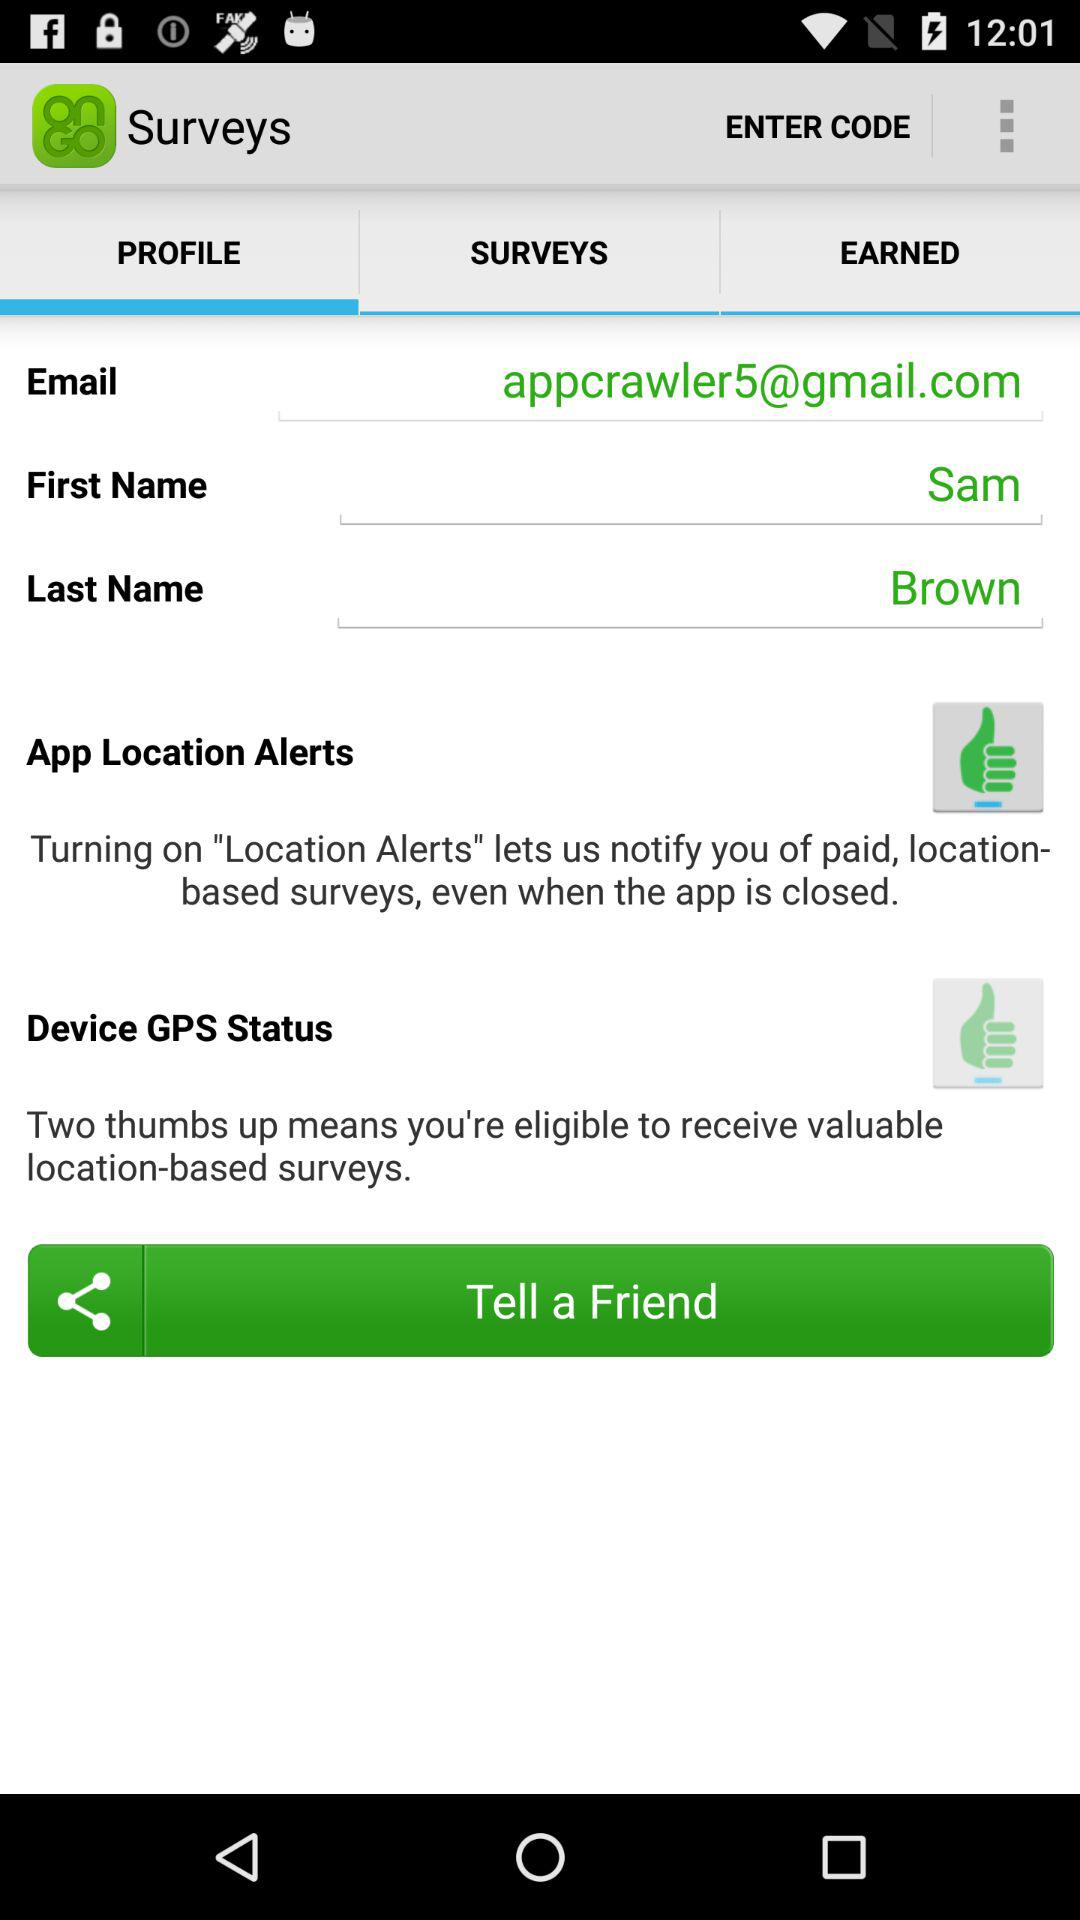What is the last name? The last name is Brown. 